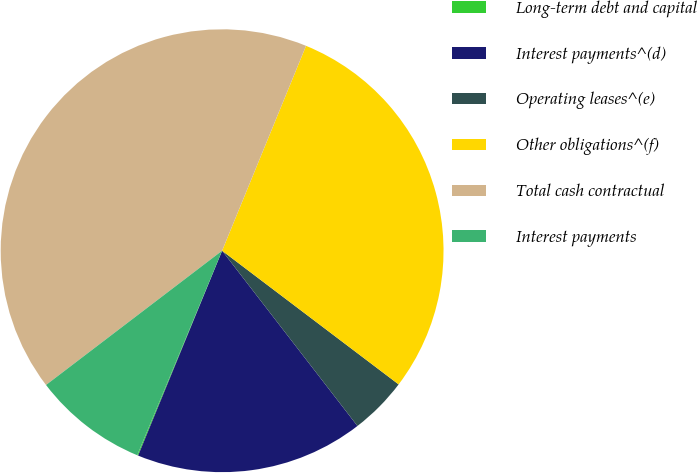Convert chart. <chart><loc_0><loc_0><loc_500><loc_500><pie_chart><fcel>Long-term debt and capital<fcel>Interest payments^(d)<fcel>Operating leases^(e)<fcel>Other obligations^(f)<fcel>Total cash contractual<fcel>Interest payments<nl><fcel>0.07%<fcel>16.66%<fcel>4.22%<fcel>29.13%<fcel>41.56%<fcel>8.37%<nl></chart> 